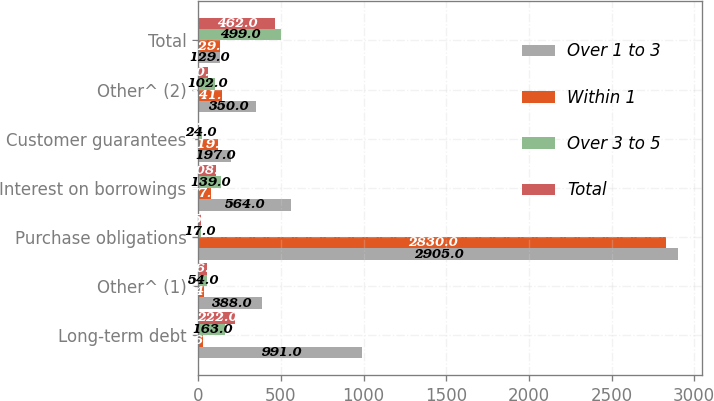<chart> <loc_0><loc_0><loc_500><loc_500><stacked_bar_chart><ecel><fcel>Long-term debt<fcel>Other^ (1)<fcel>Purchase obligations<fcel>Interest on borrowings<fcel>Customer guarantees<fcel>Other^ (2)<fcel>Total<nl><fcel>Over 1 to 3<fcel>991<fcel>388<fcel>2905<fcel>564<fcel>197<fcel>350<fcel>129<nl><fcel>Within 1<fcel>26<fcel>34<fcel>2830<fcel>77<fcel>119<fcel>141<fcel>129<nl><fcel>Over 3 to 5<fcel>163<fcel>54<fcel>17<fcel>139<fcel>24<fcel>102<fcel>499<nl><fcel>Total<fcel>222<fcel>56<fcel>15<fcel>108<fcel>1<fcel>60<fcel>462<nl></chart> 